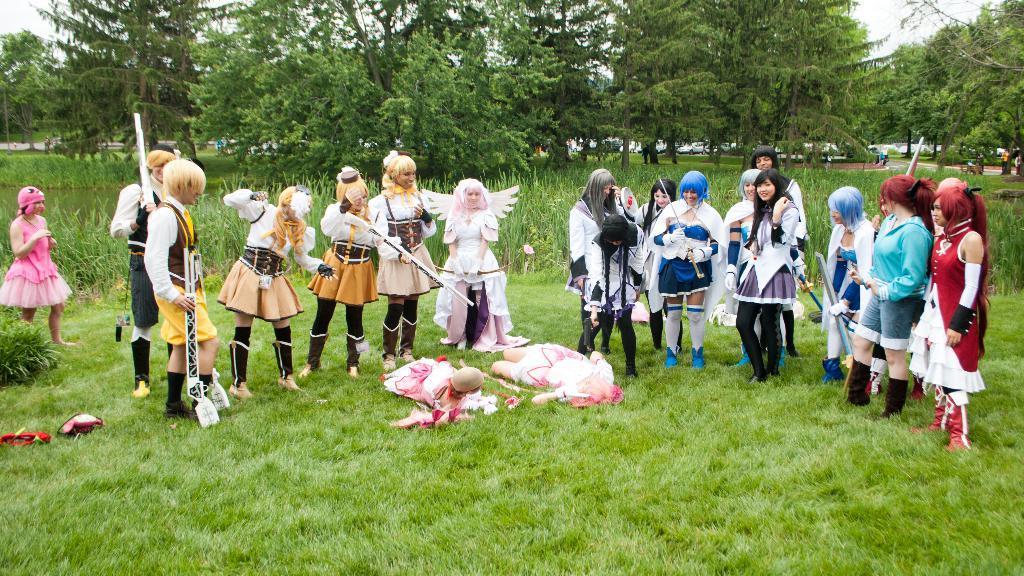Could you give a brief overview of what you see in this image? In the center of the image we can see a group of people standing on the ground holding the sticks. We can also see some objects and two people lying down on the grass. On the backside we can see some plants, cars parked aside, a group of trees and the sky which looks cloudy. 